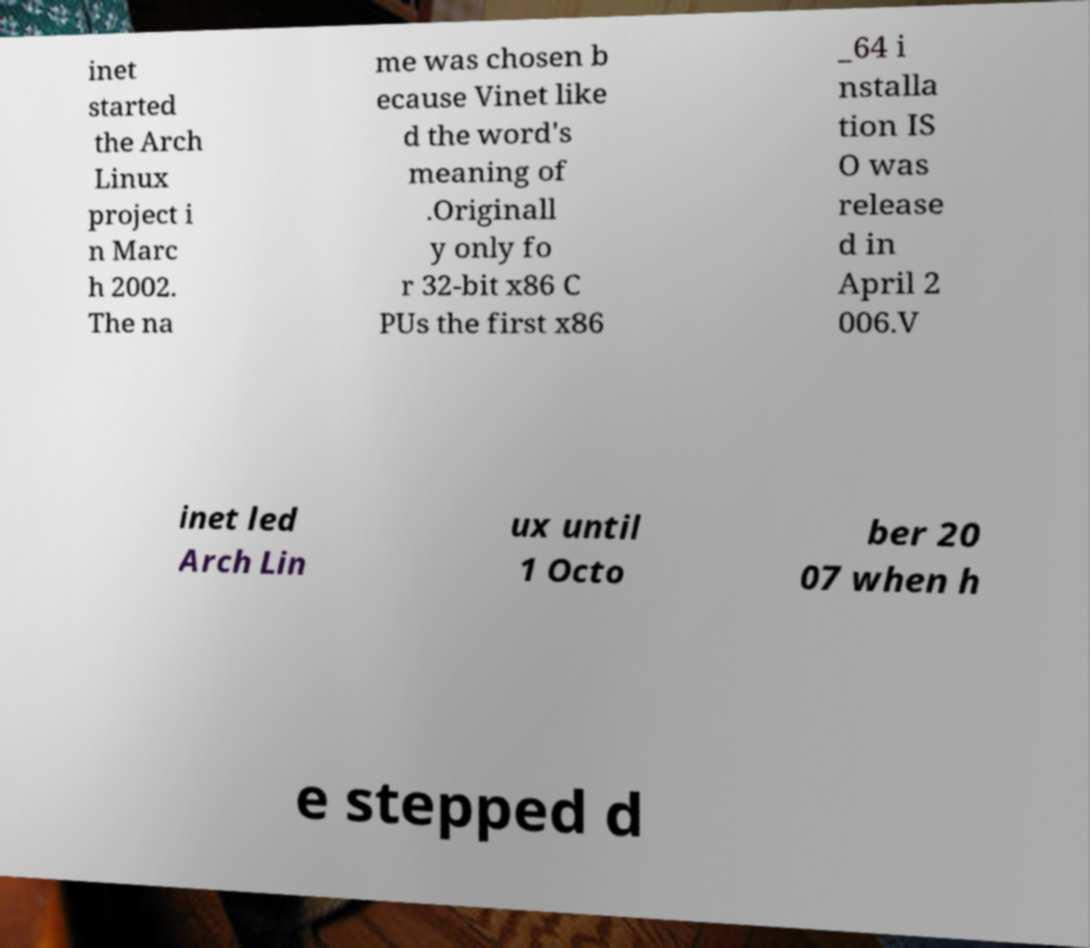Please read and relay the text visible in this image. What does it say? inet started the Arch Linux project i n Marc h 2002. The na me was chosen b ecause Vinet like d the word's meaning of .Originall y only fo r 32-bit x86 C PUs the first x86 _64 i nstalla tion IS O was release d in April 2 006.V inet led Arch Lin ux until 1 Octo ber 20 07 when h e stepped d 